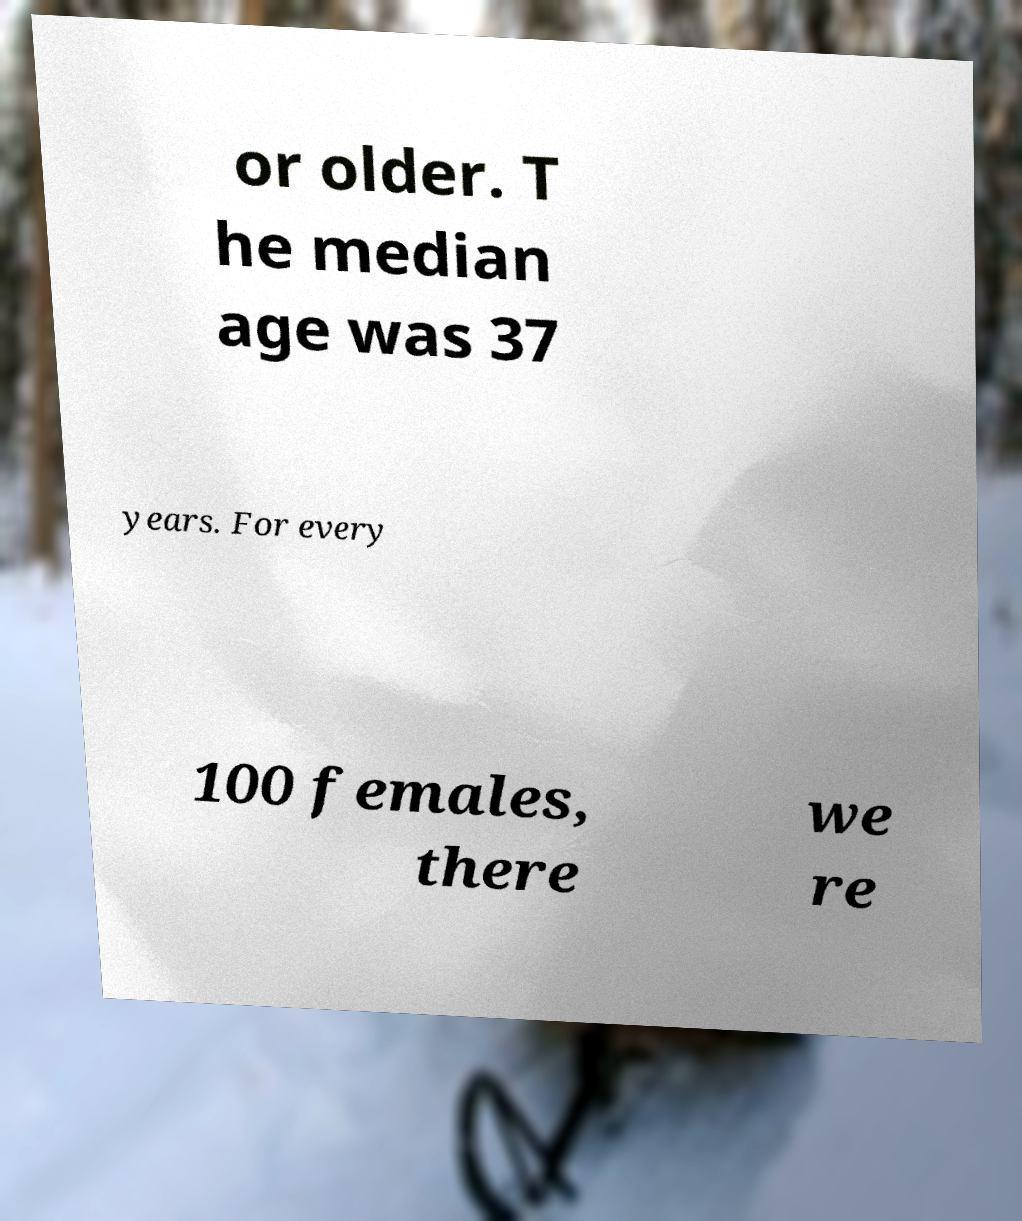I need the written content from this picture converted into text. Can you do that? or older. T he median age was 37 years. For every 100 females, there we re 